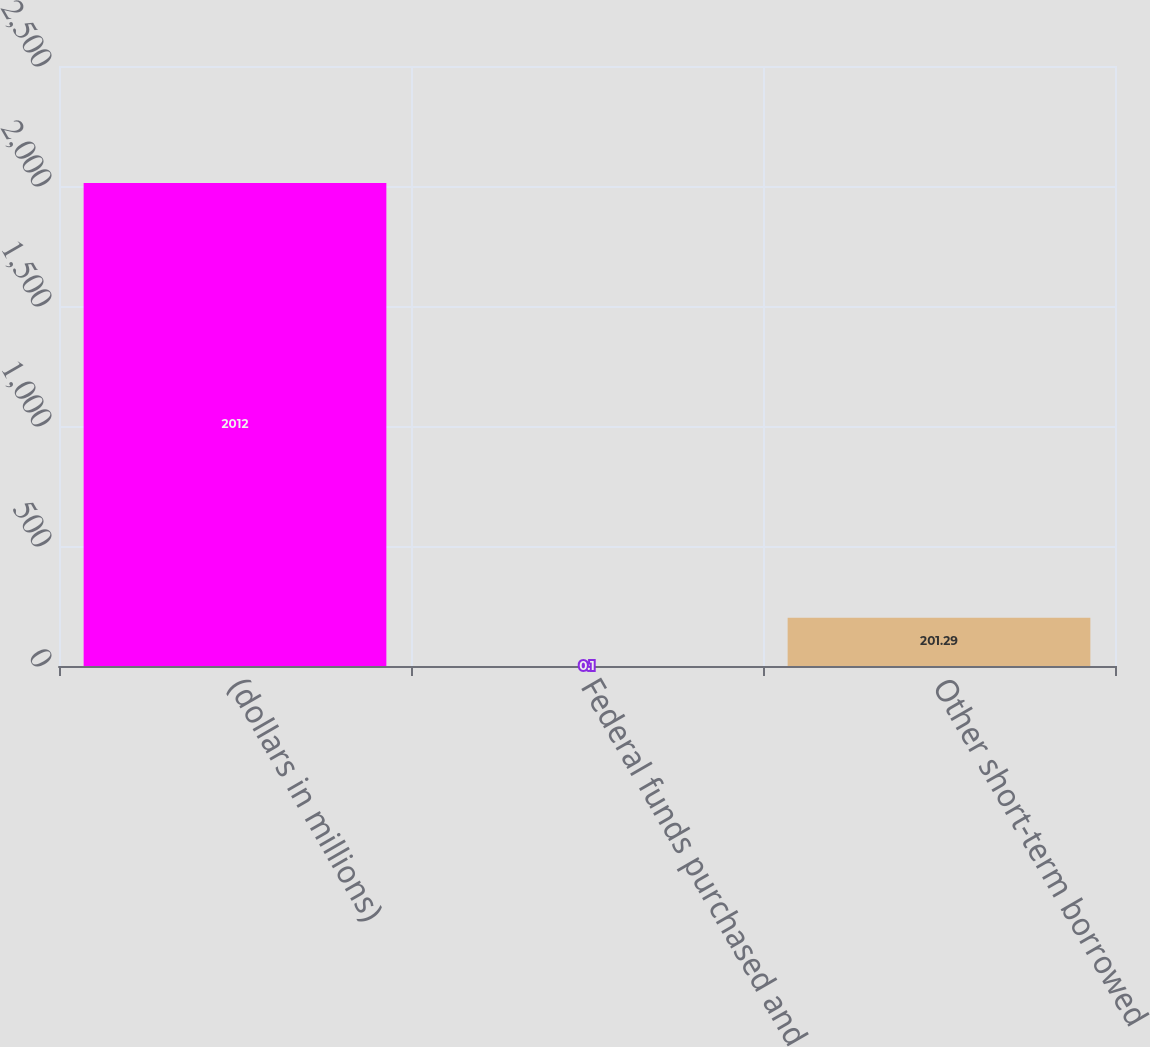<chart> <loc_0><loc_0><loc_500><loc_500><bar_chart><fcel>(dollars in millions)<fcel>Federal funds purchased and<fcel>Other short-term borrowed<nl><fcel>2012<fcel>0.1<fcel>201.29<nl></chart> 